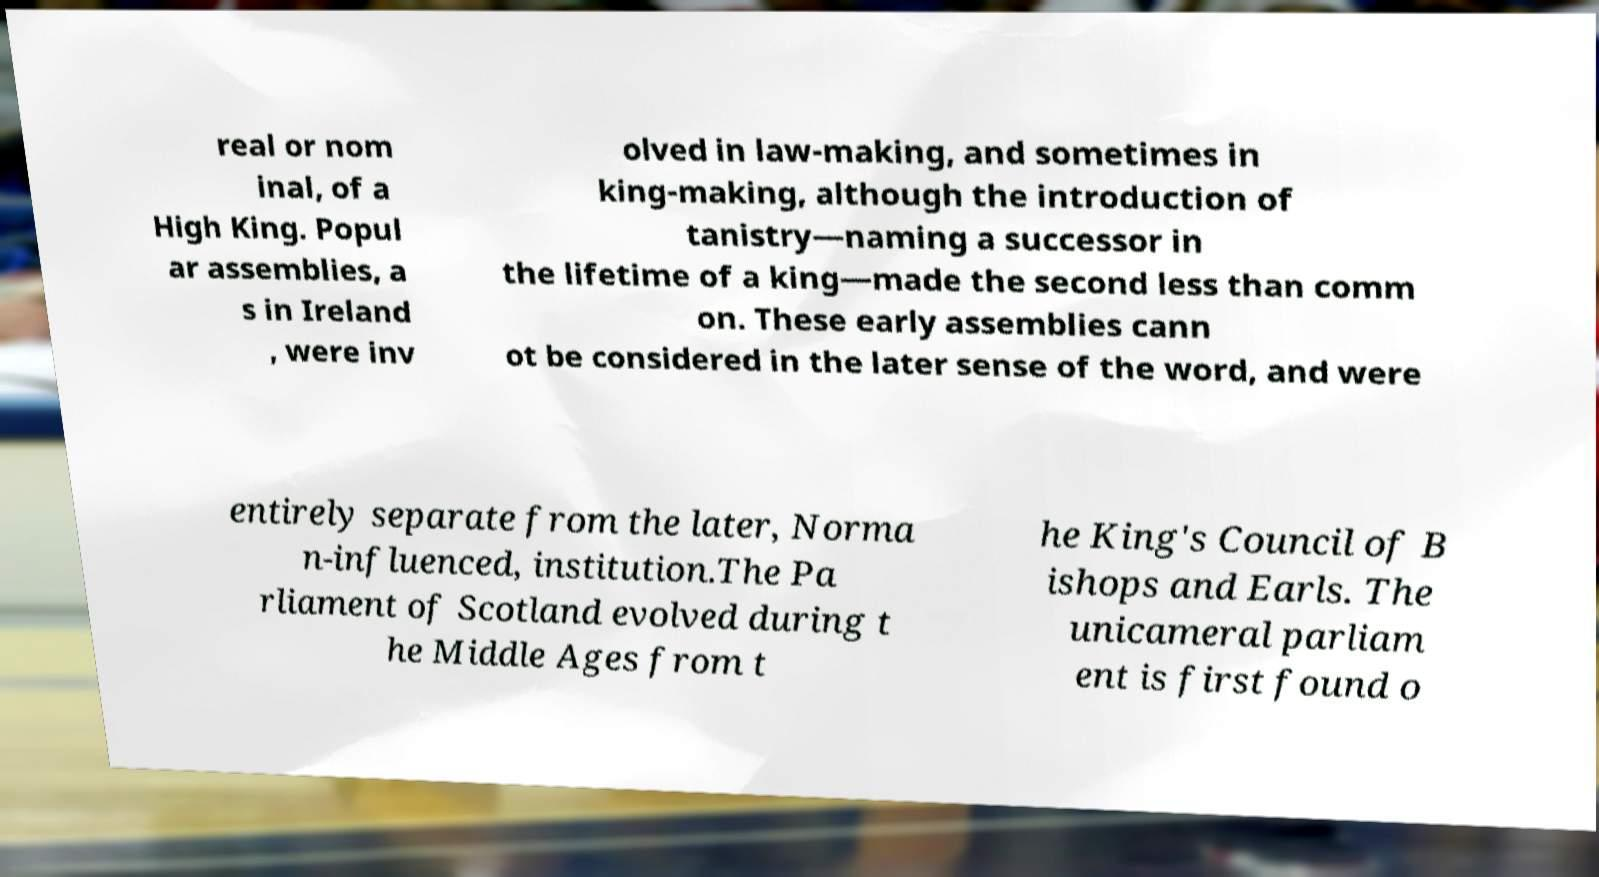What messages or text are displayed in this image? I need them in a readable, typed format. real or nom inal, of a High King. Popul ar assemblies, a s in Ireland , were inv olved in law-making, and sometimes in king-making, although the introduction of tanistry—naming a successor in the lifetime of a king—made the second less than comm on. These early assemblies cann ot be considered in the later sense of the word, and were entirely separate from the later, Norma n-influenced, institution.The Pa rliament of Scotland evolved during t he Middle Ages from t he King's Council of B ishops and Earls. The unicameral parliam ent is first found o 